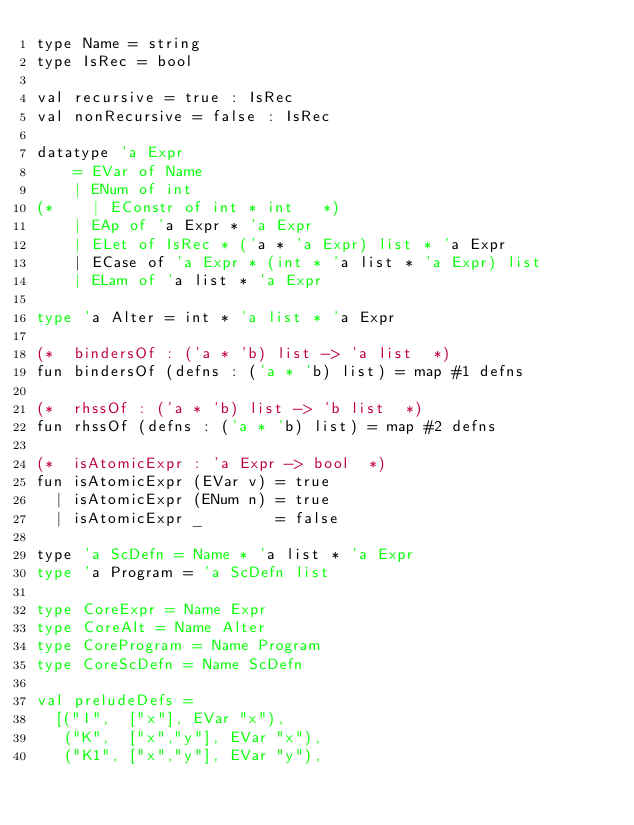Convert code to text. <code><loc_0><loc_0><loc_500><loc_500><_SML_>type Name = string
type IsRec = bool

val recursive = true : IsRec
val nonRecursive = false : IsRec

datatype 'a Expr 
    = EVar of Name
    | ENum of int
(*    | EConstr of int * int   *)
    | EAp of 'a Expr * 'a Expr
    | ELet of IsRec * ('a * 'a Expr) list * 'a Expr
    | ECase of 'a Expr * (int * 'a list * 'a Expr) list
    | ELam of 'a list * 'a Expr

type 'a Alter = int * 'a list * 'a Expr

(*  bindersOf : ('a * 'b) list -> 'a list  *)
fun bindersOf (defns : ('a * 'b) list) = map #1 defns

(*  rhssOf : ('a * 'b) list -> 'b list  *)
fun rhssOf (defns : ('a * 'b) list) = map #2 defns

(*  isAtomicExpr : 'a Expr -> bool  *)
fun isAtomicExpr (EVar v) = true
  | isAtomicExpr (ENum n) = true
  | isAtomicExpr _        = false

type 'a ScDefn = Name * 'a list * 'a Expr
type 'a Program = 'a ScDefn list

type CoreExpr = Name Expr 
type CoreAlt = Name Alter 
type CoreProgram = Name Program
type CoreScDefn = Name ScDefn

val preludeDefs = 
  [("I",  ["x"], EVar "x"),
   ("K",  ["x","y"], EVar "x"),
   ("K1", ["x","y"], EVar "y"),</code> 